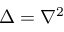Convert formula to latex. <formula><loc_0><loc_0><loc_500><loc_500>\Delta = \nabla ^ { 2 }</formula> 